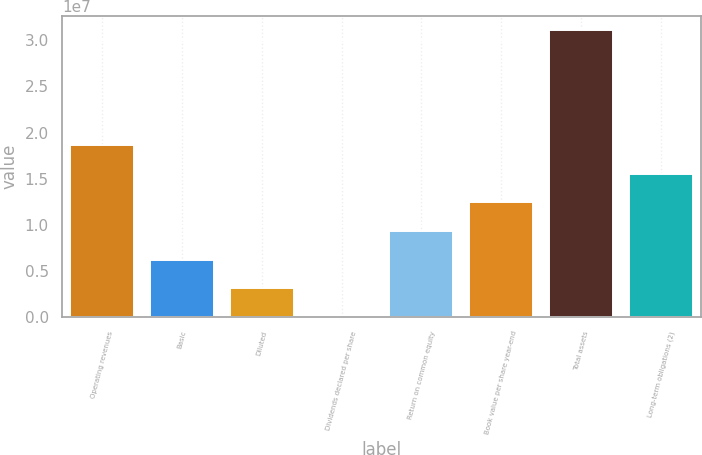Convert chart. <chart><loc_0><loc_0><loc_500><loc_500><bar_chart><fcel>Operating revenues<fcel>Basic<fcel>Diluted<fcel>Dividends declared per share<fcel>Return on common equity<fcel>Book value per share year-end<fcel>Total assets<fcel>Long-term obligations (2)<nl><fcel>1.86496e+07<fcel>6.21655e+06<fcel>3.10828e+06<fcel>2.16<fcel>9.32482e+06<fcel>1.24331e+07<fcel>3.10827e+07<fcel>1.55414e+07<nl></chart> 